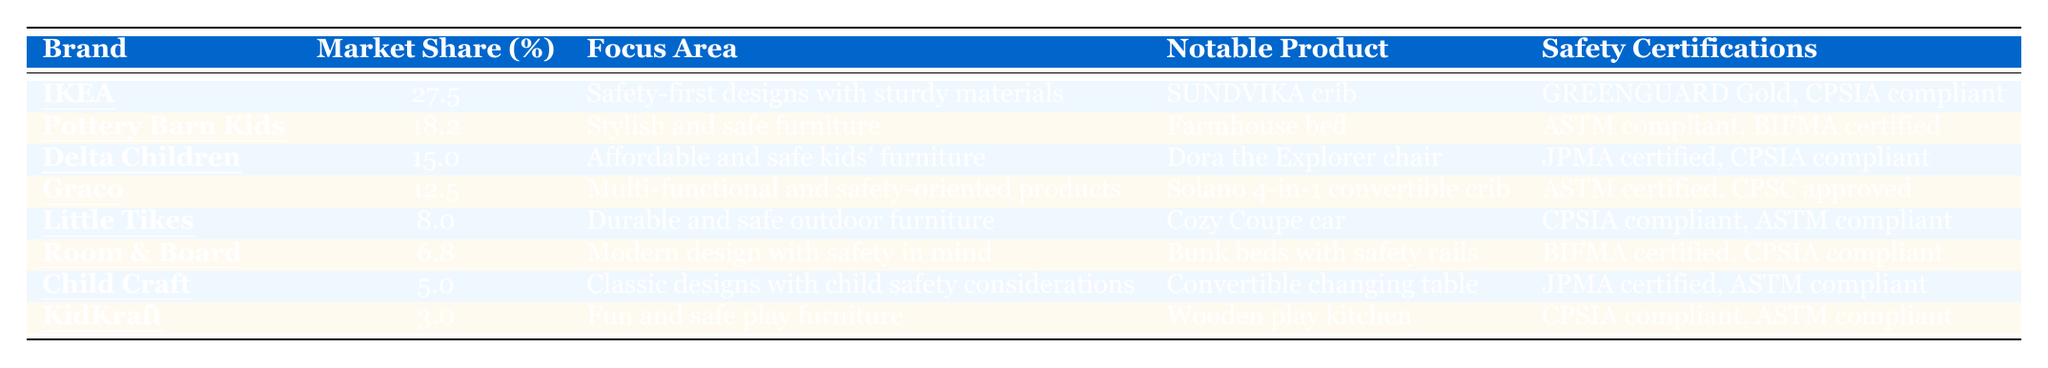What brand has the highest market share in kids' furniture designed for safety? By scanning the table, IKEA is listed at the top with a market share of 27.5%, which is higher than all other brands.
Answer: IKEA Which brand is known for its Farmhouse bed? The table indicates that Pottery Barn Kids is associated with the notable product labeled as the Farmhouse bed.
Answer: Pottery Barn Kids What is the market share percentage of Delta Children? According to the table, Delta Children has a market share of 15.0%, as explicitly stated in the respective row.
Answer: 15.0% How many brands have a market share percentage greater than 10%? The table lists four brands (IKEA, Pottery Barn Kids, Delta Children, and Graco) with market shares of 27.5%, 18.2%, 15.0%, and 12.5%, respectively; all four exceed 10%.
Answer: 4 Which brand has a notable product certified by JPMA? Delta Children has the product Dora the Explorer chair listed as JPMA certified in the safety certifications column.
Answer: Delta Children What is the total market share percentage of Little Tikes and Room & Board combined? Adding the market shares: 8.0% (Little Tikes) + 6.8% (Room & Board) gives a total of 14.8%.
Answer: 14.8% Does Graco have any products that are ASTM certified? Yes, Graco’s notable product, the Solano 4-in-1 convertible crib, is mentioned as ASTM certified in the safety certifications.
Answer: Yes If we average the market share percentages of all brands listed, what is the result? The market shares total to 96.0% (27.5 + 18.2 + 15.0 + 12.5 + 8.0 + 6.8 + 5.0 + 3.0), dividing by 8 gives an average of 12.0%.
Answer: 12.0% What is the focus area for KidKraft? The table describes KidKraft's focus area as "Fun and safe play furniture" as listed in its respective row.
Answer: Fun and safe play furniture Is the notable product from Child Craft child safety compliant? Child Craft's notable product, the Convertible changing table, is listed as JPMA certified and ASTM compliant, indicating it is indeed child safety compliant.
Answer: Yes 